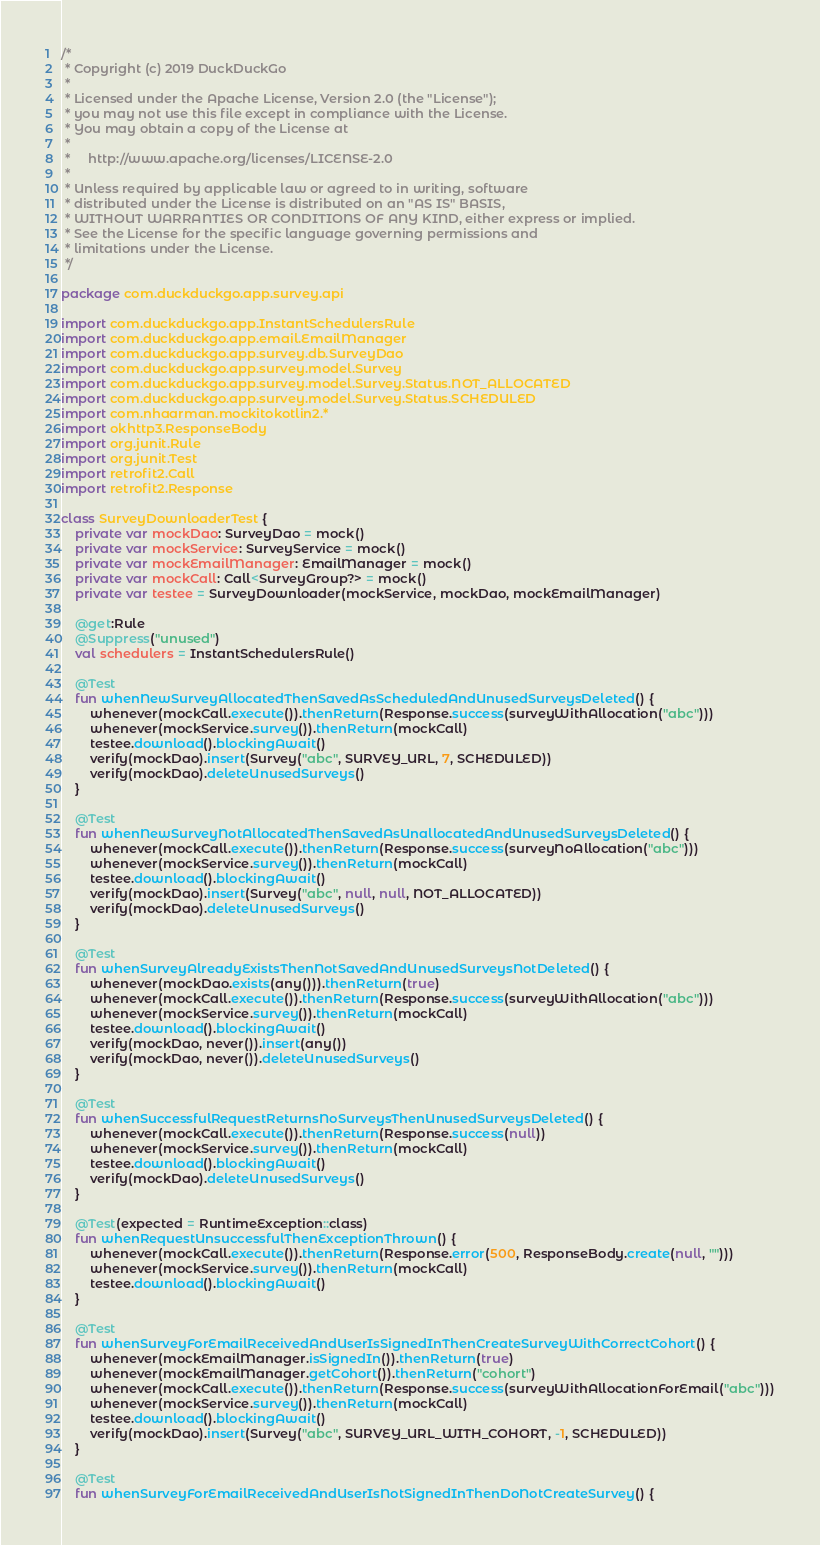Convert code to text. <code><loc_0><loc_0><loc_500><loc_500><_Kotlin_>/*
 * Copyright (c) 2019 DuckDuckGo
 *
 * Licensed under the Apache License, Version 2.0 (the "License");
 * you may not use this file except in compliance with the License.
 * You may obtain a copy of the License at
 *
 *     http://www.apache.org/licenses/LICENSE-2.0
 *
 * Unless required by applicable law or agreed to in writing, software
 * distributed under the License is distributed on an "AS IS" BASIS,
 * WITHOUT WARRANTIES OR CONDITIONS OF ANY KIND, either express or implied.
 * See the License for the specific language governing permissions and
 * limitations under the License.
 */

package com.duckduckgo.app.survey.api

import com.duckduckgo.app.InstantSchedulersRule
import com.duckduckgo.app.email.EmailManager
import com.duckduckgo.app.survey.db.SurveyDao
import com.duckduckgo.app.survey.model.Survey
import com.duckduckgo.app.survey.model.Survey.Status.NOT_ALLOCATED
import com.duckduckgo.app.survey.model.Survey.Status.SCHEDULED
import com.nhaarman.mockitokotlin2.*
import okhttp3.ResponseBody
import org.junit.Rule
import org.junit.Test
import retrofit2.Call
import retrofit2.Response

class SurveyDownloaderTest {
    private var mockDao: SurveyDao = mock()
    private var mockService: SurveyService = mock()
    private var mockEmailManager: EmailManager = mock()
    private var mockCall: Call<SurveyGroup?> = mock()
    private var testee = SurveyDownloader(mockService, mockDao, mockEmailManager)

    @get:Rule
    @Suppress("unused")
    val schedulers = InstantSchedulersRule()

    @Test
    fun whenNewSurveyAllocatedThenSavedAsScheduledAndUnusedSurveysDeleted() {
        whenever(mockCall.execute()).thenReturn(Response.success(surveyWithAllocation("abc")))
        whenever(mockService.survey()).thenReturn(mockCall)
        testee.download().blockingAwait()
        verify(mockDao).insert(Survey("abc", SURVEY_URL, 7, SCHEDULED))
        verify(mockDao).deleteUnusedSurveys()
    }

    @Test
    fun whenNewSurveyNotAllocatedThenSavedAsUnallocatedAndUnusedSurveysDeleted() {
        whenever(mockCall.execute()).thenReturn(Response.success(surveyNoAllocation("abc")))
        whenever(mockService.survey()).thenReturn(mockCall)
        testee.download().blockingAwait()
        verify(mockDao).insert(Survey("abc", null, null, NOT_ALLOCATED))
        verify(mockDao).deleteUnusedSurveys()
    }

    @Test
    fun whenSurveyAlreadyExistsThenNotSavedAndUnusedSurveysNotDeleted() {
        whenever(mockDao.exists(any())).thenReturn(true)
        whenever(mockCall.execute()).thenReturn(Response.success(surveyWithAllocation("abc")))
        whenever(mockService.survey()).thenReturn(mockCall)
        testee.download().blockingAwait()
        verify(mockDao, never()).insert(any())
        verify(mockDao, never()).deleteUnusedSurveys()
    }

    @Test
    fun whenSuccessfulRequestReturnsNoSurveysThenUnusedSurveysDeleted() {
        whenever(mockCall.execute()).thenReturn(Response.success(null))
        whenever(mockService.survey()).thenReturn(mockCall)
        testee.download().blockingAwait()
        verify(mockDao).deleteUnusedSurveys()
    }

    @Test(expected = RuntimeException::class)
    fun whenRequestUnsuccessfulThenExceptionThrown() {
        whenever(mockCall.execute()).thenReturn(Response.error(500, ResponseBody.create(null, "")))
        whenever(mockService.survey()).thenReturn(mockCall)
        testee.download().blockingAwait()
    }

    @Test
    fun whenSurveyForEmailReceivedAndUserIsSignedInThenCreateSurveyWithCorrectCohort() {
        whenever(mockEmailManager.isSignedIn()).thenReturn(true)
        whenever(mockEmailManager.getCohort()).thenReturn("cohort")
        whenever(mockCall.execute()).thenReturn(Response.success(surveyWithAllocationForEmail("abc")))
        whenever(mockService.survey()).thenReturn(mockCall)
        testee.download().blockingAwait()
        verify(mockDao).insert(Survey("abc", SURVEY_URL_WITH_COHORT, -1, SCHEDULED))
    }

    @Test
    fun whenSurveyForEmailReceivedAndUserIsNotSignedInThenDoNotCreateSurvey() {</code> 